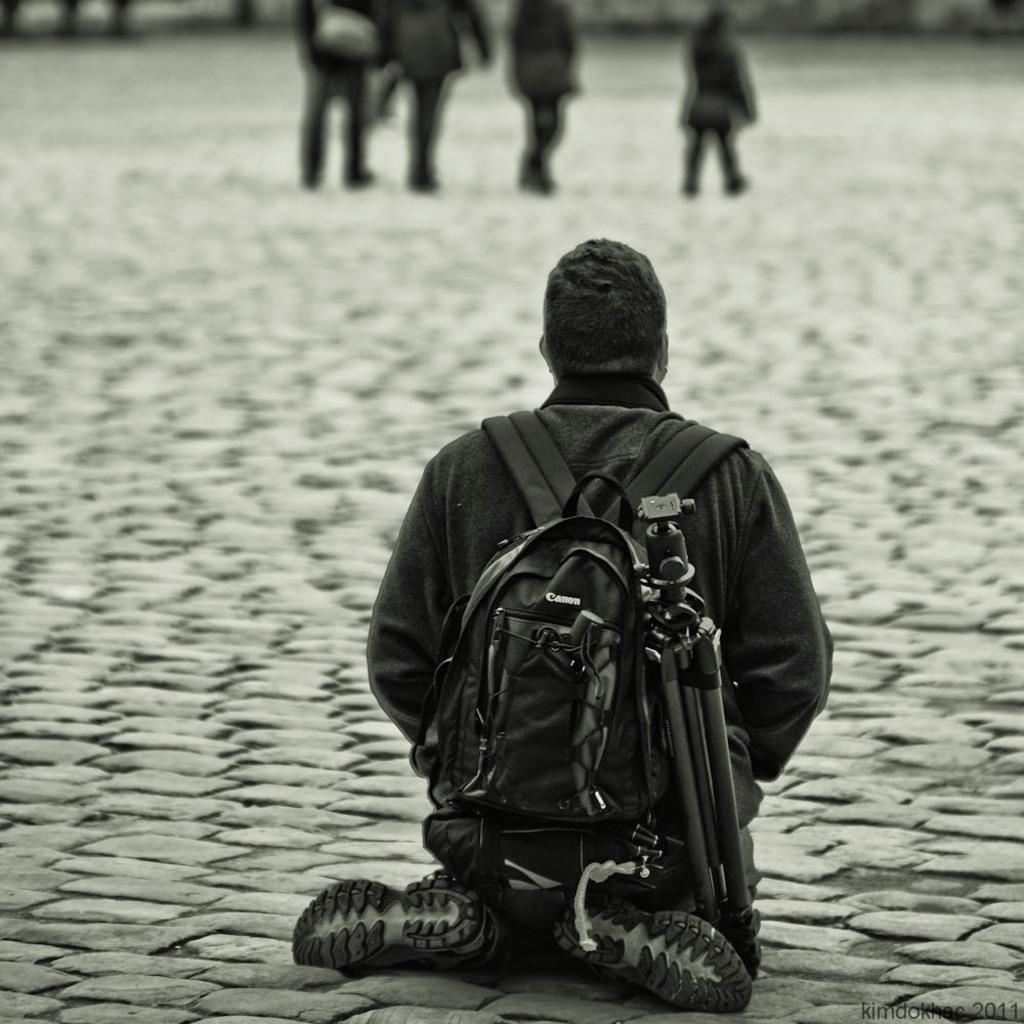Describe this image in one or two sentences. In this picture we can see a person carrying a bag, sitting on the ground and in the background we can see some people. 